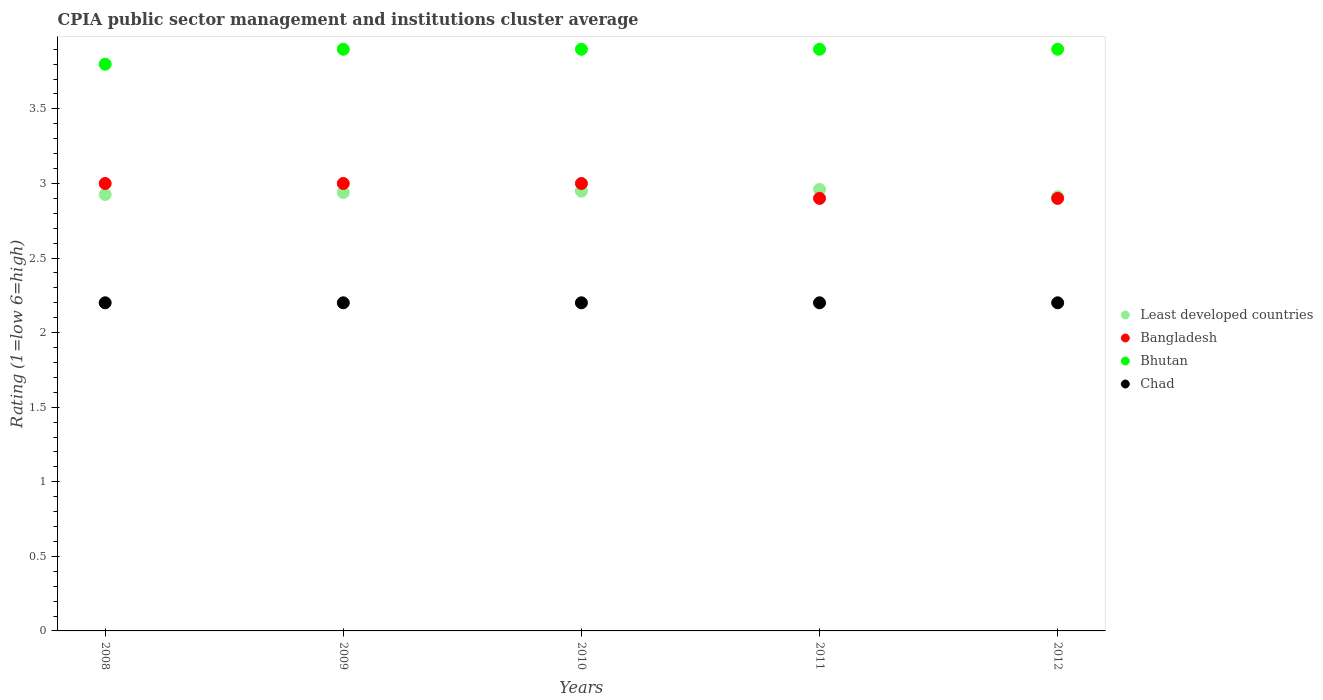How many different coloured dotlines are there?
Provide a succinct answer. 4. Is the number of dotlines equal to the number of legend labels?
Keep it short and to the point. Yes. What is the CPIA rating in Least developed countries in 2010?
Offer a terse response. 2.95. Across all years, what is the maximum CPIA rating in Bangladesh?
Make the answer very short. 3. What is the total CPIA rating in Bangladesh in the graph?
Make the answer very short. 14.8. What is the difference between the CPIA rating in Chad in 2008 and that in 2009?
Keep it short and to the point. 0. What is the difference between the CPIA rating in Bangladesh in 2010 and the CPIA rating in Bhutan in 2012?
Offer a very short reply. -0.9. What is the average CPIA rating in Chad per year?
Your response must be concise. 2.2. In how many years, is the CPIA rating in Bangladesh greater than 2.6?
Your answer should be very brief. 5. What is the ratio of the CPIA rating in Bangladesh in 2011 to that in 2012?
Offer a very short reply. 1. Is the CPIA rating in Bhutan in 2009 less than that in 2011?
Your answer should be compact. No. What is the difference between the highest and the lowest CPIA rating in Bhutan?
Your response must be concise. 0.1. In how many years, is the CPIA rating in Bangladesh greater than the average CPIA rating in Bangladesh taken over all years?
Give a very brief answer. 3. Is it the case that in every year, the sum of the CPIA rating in Least developed countries and CPIA rating in Bhutan  is greater than the sum of CPIA rating in Chad and CPIA rating in Bangladesh?
Provide a succinct answer. No. Is it the case that in every year, the sum of the CPIA rating in Chad and CPIA rating in Bangladesh  is greater than the CPIA rating in Least developed countries?
Offer a terse response. Yes. Does the CPIA rating in Chad monotonically increase over the years?
Offer a terse response. No. How many dotlines are there?
Keep it short and to the point. 4. Are the values on the major ticks of Y-axis written in scientific E-notation?
Offer a very short reply. No. How many legend labels are there?
Your answer should be compact. 4. How are the legend labels stacked?
Give a very brief answer. Vertical. What is the title of the graph?
Provide a short and direct response. CPIA public sector management and institutions cluster average. What is the Rating (1=low 6=high) in Least developed countries in 2008?
Give a very brief answer. 2.93. What is the Rating (1=low 6=high) in Least developed countries in 2009?
Ensure brevity in your answer.  2.94. What is the Rating (1=low 6=high) of Bangladesh in 2009?
Your answer should be compact. 3. What is the Rating (1=low 6=high) of Chad in 2009?
Your response must be concise. 2.2. What is the Rating (1=low 6=high) in Least developed countries in 2010?
Ensure brevity in your answer.  2.95. What is the Rating (1=low 6=high) in Bangladesh in 2010?
Provide a short and direct response. 3. What is the Rating (1=low 6=high) of Chad in 2010?
Give a very brief answer. 2.2. What is the Rating (1=low 6=high) in Least developed countries in 2011?
Give a very brief answer. 2.96. What is the Rating (1=low 6=high) of Bangladesh in 2011?
Provide a short and direct response. 2.9. What is the Rating (1=low 6=high) of Chad in 2011?
Provide a succinct answer. 2.2. What is the Rating (1=low 6=high) in Least developed countries in 2012?
Offer a very short reply. 2.91. What is the Rating (1=low 6=high) in Bhutan in 2012?
Provide a succinct answer. 3.9. What is the Rating (1=low 6=high) of Chad in 2012?
Offer a very short reply. 2.2. Across all years, what is the maximum Rating (1=low 6=high) of Least developed countries?
Give a very brief answer. 2.96. Across all years, what is the maximum Rating (1=low 6=high) of Bhutan?
Provide a short and direct response. 3.9. Across all years, what is the maximum Rating (1=low 6=high) in Chad?
Provide a succinct answer. 2.2. Across all years, what is the minimum Rating (1=low 6=high) in Least developed countries?
Give a very brief answer. 2.91. Across all years, what is the minimum Rating (1=low 6=high) of Bhutan?
Provide a succinct answer. 3.8. What is the total Rating (1=low 6=high) of Least developed countries in the graph?
Your answer should be compact. 14.69. What is the total Rating (1=low 6=high) of Bangladesh in the graph?
Provide a short and direct response. 14.8. What is the total Rating (1=low 6=high) in Bhutan in the graph?
Your answer should be compact. 19.4. What is the total Rating (1=low 6=high) in Chad in the graph?
Provide a short and direct response. 11. What is the difference between the Rating (1=low 6=high) in Least developed countries in 2008 and that in 2009?
Offer a terse response. -0.01. What is the difference between the Rating (1=low 6=high) in Bhutan in 2008 and that in 2009?
Your response must be concise. -0.1. What is the difference between the Rating (1=low 6=high) of Chad in 2008 and that in 2009?
Provide a succinct answer. 0. What is the difference between the Rating (1=low 6=high) in Least developed countries in 2008 and that in 2010?
Your answer should be very brief. -0.02. What is the difference between the Rating (1=low 6=high) in Bangladesh in 2008 and that in 2010?
Make the answer very short. 0. What is the difference between the Rating (1=low 6=high) in Bhutan in 2008 and that in 2010?
Offer a terse response. -0.1. What is the difference between the Rating (1=low 6=high) of Least developed countries in 2008 and that in 2011?
Your answer should be compact. -0.03. What is the difference between the Rating (1=low 6=high) in Least developed countries in 2008 and that in 2012?
Give a very brief answer. 0.02. What is the difference between the Rating (1=low 6=high) of Chad in 2008 and that in 2012?
Your response must be concise. 0. What is the difference between the Rating (1=low 6=high) in Least developed countries in 2009 and that in 2010?
Give a very brief answer. -0.01. What is the difference between the Rating (1=low 6=high) of Bhutan in 2009 and that in 2010?
Your response must be concise. 0. What is the difference between the Rating (1=low 6=high) of Chad in 2009 and that in 2010?
Make the answer very short. 0. What is the difference between the Rating (1=low 6=high) of Least developed countries in 2009 and that in 2011?
Offer a very short reply. -0.02. What is the difference between the Rating (1=low 6=high) of Bangladesh in 2009 and that in 2011?
Your answer should be compact. 0.1. What is the difference between the Rating (1=low 6=high) of Chad in 2009 and that in 2011?
Your answer should be very brief. 0. What is the difference between the Rating (1=low 6=high) of Least developed countries in 2009 and that in 2012?
Offer a very short reply. 0.03. What is the difference between the Rating (1=low 6=high) of Bhutan in 2009 and that in 2012?
Ensure brevity in your answer.  0. What is the difference between the Rating (1=low 6=high) of Least developed countries in 2010 and that in 2011?
Your answer should be compact. -0.01. What is the difference between the Rating (1=low 6=high) of Bangladesh in 2010 and that in 2011?
Provide a succinct answer. 0.1. What is the difference between the Rating (1=low 6=high) in Bhutan in 2010 and that in 2011?
Your response must be concise. 0. What is the difference between the Rating (1=low 6=high) in Least developed countries in 2010 and that in 2012?
Provide a succinct answer. 0.04. What is the difference between the Rating (1=low 6=high) in Bangladesh in 2010 and that in 2012?
Offer a terse response. 0.1. What is the difference between the Rating (1=low 6=high) in Chad in 2010 and that in 2012?
Provide a short and direct response. 0. What is the difference between the Rating (1=low 6=high) in Least developed countries in 2011 and that in 2012?
Keep it short and to the point. 0.05. What is the difference between the Rating (1=low 6=high) in Least developed countries in 2008 and the Rating (1=low 6=high) in Bangladesh in 2009?
Your response must be concise. -0.07. What is the difference between the Rating (1=low 6=high) in Least developed countries in 2008 and the Rating (1=low 6=high) in Bhutan in 2009?
Give a very brief answer. -0.97. What is the difference between the Rating (1=low 6=high) in Least developed countries in 2008 and the Rating (1=low 6=high) in Chad in 2009?
Provide a succinct answer. 0.73. What is the difference between the Rating (1=low 6=high) of Bangladesh in 2008 and the Rating (1=low 6=high) of Bhutan in 2009?
Make the answer very short. -0.9. What is the difference between the Rating (1=low 6=high) of Bangladesh in 2008 and the Rating (1=low 6=high) of Chad in 2009?
Keep it short and to the point. 0.8. What is the difference between the Rating (1=low 6=high) in Least developed countries in 2008 and the Rating (1=low 6=high) in Bangladesh in 2010?
Your answer should be compact. -0.07. What is the difference between the Rating (1=low 6=high) of Least developed countries in 2008 and the Rating (1=low 6=high) of Bhutan in 2010?
Offer a very short reply. -0.97. What is the difference between the Rating (1=low 6=high) of Least developed countries in 2008 and the Rating (1=low 6=high) of Chad in 2010?
Your answer should be very brief. 0.73. What is the difference between the Rating (1=low 6=high) of Bangladesh in 2008 and the Rating (1=low 6=high) of Bhutan in 2010?
Provide a succinct answer. -0.9. What is the difference between the Rating (1=low 6=high) in Bangladesh in 2008 and the Rating (1=low 6=high) in Chad in 2010?
Offer a very short reply. 0.8. What is the difference between the Rating (1=low 6=high) in Least developed countries in 2008 and the Rating (1=low 6=high) in Bangladesh in 2011?
Provide a succinct answer. 0.03. What is the difference between the Rating (1=low 6=high) in Least developed countries in 2008 and the Rating (1=low 6=high) in Bhutan in 2011?
Provide a succinct answer. -0.97. What is the difference between the Rating (1=low 6=high) in Least developed countries in 2008 and the Rating (1=low 6=high) in Chad in 2011?
Keep it short and to the point. 0.73. What is the difference between the Rating (1=low 6=high) of Bangladesh in 2008 and the Rating (1=low 6=high) of Bhutan in 2011?
Make the answer very short. -0.9. What is the difference between the Rating (1=low 6=high) in Least developed countries in 2008 and the Rating (1=low 6=high) in Bangladesh in 2012?
Offer a very short reply. 0.03. What is the difference between the Rating (1=low 6=high) of Least developed countries in 2008 and the Rating (1=low 6=high) of Bhutan in 2012?
Keep it short and to the point. -0.97. What is the difference between the Rating (1=low 6=high) of Least developed countries in 2008 and the Rating (1=low 6=high) of Chad in 2012?
Your response must be concise. 0.73. What is the difference between the Rating (1=low 6=high) of Bangladesh in 2008 and the Rating (1=low 6=high) of Bhutan in 2012?
Give a very brief answer. -0.9. What is the difference between the Rating (1=low 6=high) in Bangladesh in 2008 and the Rating (1=low 6=high) in Chad in 2012?
Provide a short and direct response. 0.8. What is the difference between the Rating (1=low 6=high) of Bhutan in 2008 and the Rating (1=low 6=high) of Chad in 2012?
Offer a terse response. 1.6. What is the difference between the Rating (1=low 6=high) in Least developed countries in 2009 and the Rating (1=low 6=high) in Bangladesh in 2010?
Ensure brevity in your answer.  -0.06. What is the difference between the Rating (1=low 6=high) in Least developed countries in 2009 and the Rating (1=low 6=high) in Bhutan in 2010?
Ensure brevity in your answer.  -0.96. What is the difference between the Rating (1=low 6=high) of Least developed countries in 2009 and the Rating (1=low 6=high) of Chad in 2010?
Your response must be concise. 0.74. What is the difference between the Rating (1=low 6=high) of Bangladesh in 2009 and the Rating (1=low 6=high) of Bhutan in 2010?
Ensure brevity in your answer.  -0.9. What is the difference between the Rating (1=low 6=high) of Bangladesh in 2009 and the Rating (1=low 6=high) of Chad in 2010?
Keep it short and to the point. 0.8. What is the difference between the Rating (1=low 6=high) in Least developed countries in 2009 and the Rating (1=low 6=high) in Bangladesh in 2011?
Provide a succinct answer. 0.04. What is the difference between the Rating (1=low 6=high) in Least developed countries in 2009 and the Rating (1=low 6=high) in Bhutan in 2011?
Keep it short and to the point. -0.96. What is the difference between the Rating (1=low 6=high) in Least developed countries in 2009 and the Rating (1=low 6=high) in Chad in 2011?
Keep it short and to the point. 0.74. What is the difference between the Rating (1=low 6=high) in Bangladesh in 2009 and the Rating (1=low 6=high) in Bhutan in 2011?
Offer a terse response. -0.9. What is the difference between the Rating (1=low 6=high) of Bangladesh in 2009 and the Rating (1=low 6=high) of Chad in 2011?
Make the answer very short. 0.8. What is the difference between the Rating (1=low 6=high) in Least developed countries in 2009 and the Rating (1=low 6=high) in Bangladesh in 2012?
Give a very brief answer. 0.04. What is the difference between the Rating (1=low 6=high) in Least developed countries in 2009 and the Rating (1=low 6=high) in Bhutan in 2012?
Provide a succinct answer. -0.96. What is the difference between the Rating (1=low 6=high) in Least developed countries in 2009 and the Rating (1=low 6=high) in Chad in 2012?
Your answer should be very brief. 0.74. What is the difference between the Rating (1=low 6=high) of Bangladesh in 2009 and the Rating (1=low 6=high) of Bhutan in 2012?
Provide a short and direct response. -0.9. What is the difference between the Rating (1=low 6=high) of Least developed countries in 2010 and the Rating (1=low 6=high) of Bangladesh in 2011?
Keep it short and to the point. 0.05. What is the difference between the Rating (1=low 6=high) in Least developed countries in 2010 and the Rating (1=low 6=high) in Bhutan in 2011?
Ensure brevity in your answer.  -0.95. What is the difference between the Rating (1=low 6=high) in Least developed countries in 2010 and the Rating (1=low 6=high) in Chad in 2011?
Your response must be concise. 0.75. What is the difference between the Rating (1=low 6=high) of Least developed countries in 2010 and the Rating (1=low 6=high) of Bangladesh in 2012?
Make the answer very short. 0.05. What is the difference between the Rating (1=low 6=high) of Least developed countries in 2010 and the Rating (1=low 6=high) of Bhutan in 2012?
Keep it short and to the point. -0.95. What is the difference between the Rating (1=low 6=high) in Least developed countries in 2010 and the Rating (1=low 6=high) in Chad in 2012?
Your response must be concise. 0.75. What is the difference between the Rating (1=low 6=high) of Bangladesh in 2010 and the Rating (1=low 6=high) of Chad in 2012?
Provide a short and direct response. 0.8. What is the difference between the Rating (1=low 6=high) in Least developed countries in 2011 and the Rating (1=low 6=high) in Bangladesh in 2012?
Provide a succinct answer. 0.06. What is the difference between the Rating (1=low 6=high) of Least developed countries in 2011 and the Rating (1=low 6=high) of Bhutan in 2012?
Offer a terse response. -0.94. What is the difference between the Rating (1=low 6=high) of Least developed countries in 2011 and the Rating (1=low 6=high) of Chad in 2012?
Keep it short and to the point. 0.76. What is the difference between the Rating (1=low 6=high) of Bangladesh in 2011 and the Rating (1=low 6=high) of Chad in 2012?
Offer a terse response. 0.7. What is the difference between the Rating (1=low 6=high) of Bhutan in 2011 and the Rating (1=low 6=high) of Chad in 2012?
Keep it short and to the point. 1.7. What is the average Rating (1=low 6=high) of Least developed countries per year?
Provide a succinct answer. 2.94. What is the average Rating (1=low 6=high) in Bangladesh per year?
Ensure brevity in your answer.  2.96. What is the average Rating (1=low 6=high) in Bhutan per year?
Your answer should be very brief. 3.88. In the year 2008, what is the difference between the Rating (1=low 6=high) in Least developed countries and Rating (1=low 6=high) in Bangladesh?
Give a very brief answer. -0.07. In the year 2008, what is the difference between the Rating (1=low 6=high) in Least developed countries and Rating (1=low 6=high) in Bhutan?
Give a very brief answer. -0.87. In the year 2008, what is the difference between the Rating (1=low 6=high) in Least developed countries and Rating (1=low 6=high) in Chad?
Keep it short and to the point. 0.73. In the year 2008, what is the difference between the Rating (1=low 6=high) of Bangladesh and Rating (1=low 6=high) of Bhutan?
Your answer should be compact. -0.8. In the year 2008, what is the difference between the Rating (1=low 6=high) of Bangladesh and Rating (1=low 6=high) of Chad?
Your response must be concise. 0.8. In the year 2009, what is the difference between the Rating (1=low 6=high) in Least developed countries and Rating (1=low 6=high) in Bangladesh?
Offer a terse response. -0.06. In the year 2009, what is the difference between the Rating (1=low 6=high) in Least developed countries and Rating (1=low 6=high) in Bhutan?
Provide a succinct answer. -0.96. In the year 2009, what is the difference between the Rating (1=low 6=high) of Least developed countries and Rating (1=low 6=high) of Chad?
Your response must be concise. 0.74. In the year 2009, what is the difference between the Rating (1=low 6=high) in Bangladesh and Rating (1=low 6=high) in Bhutan?
Your answer should be very brief. -0.9. In the year 2009, what is the difference between the Rating (1=low 6=high) of Bangladesh and Rating (1=low 6=high) of Chad?
Ensure brevity in your answer.  0.8. In the year 2009, what is the difference between the Rating (1=low 6=high) in Bhutan and Rating (1=low 6=high) in Chad?
Provide a succinct answer. 1.7. In the year 2010, what is the difference between the Rating (1=low 6=high) in Least developed countries and Rating (1=low 6=high) in Bangladesh?
Your answer should be compact. -0.05. In the year 2010, what is the difference between the Rating (1=low 6=high) of Least developed countries and Rating (1=low 6=high) of Bhutan?
Provide a succinct answer. -0.95. In the year 2010, what is the difference between the Rating (1=low 6=high) in Least developed countries and Rating (1=low 6=high) in Chad?
Offer a very short reply. 0.75. In the year 2010, what is the difference between the Rating (1=low 6=high) in Bangladesh and Rating (1=low 6=high) in Chad?
Ensure brevity in your answer.  0.8. In the year 2010, what is the difference between the Rating (1=low 6=high) of Bhutan and Rating (1=low 6=high) of Chad?
Provide a succinct answer. 1.7. In the year 2011, what is the difference between the Rating (1=low 6=high) in Least developed countries and Rating (1=low 6=high) in Bangladesh?
Your answer should be compact. 0.06. In the year 2011, what is the difference between the Rating (1=low 6=high) of Least developed countries and Rating (1=low 6=high) of Bhutan?
Keep it short and to the point. -0.94. In the year 2011, what is the difference between the Rating (1=low 6=high) in Least developed countries and Rating (1=low 6=high) in Chad?
Your answer should be very brief. 0.76. In the year 2011, what is the difference between the Rating (1=low 6=high) in Bangladesh and Rating (1=low 6=high) in Chad?
Ensure brevity in your answer.  0.7. In the year 2012, what is the difference between the Rating (1=low 6=high) of Least developed countries and Rating (1=low 6=high) of Bangladesh?
Offer a terse response. 0.01. In the year 2012, what is the difference between the Rating (1=low 6=high) in Least developed countries and Rating (1=low 6=high) in Bhutan?
Offer a terse response. -0.99. In the year 2012, what is the difference between the Rating (1=low 6=high) in Least developed countries and Rating (1=low 6=high) in Chad?
Your answer should be very brief. 0.71. In the year 2012, what is the difference between the Rating (1=low 6=high) of Bangladesh and Rating (1=low 6=high) of Bhutan?
Offer a terse response. -1. In the year 2012, what is the difference between the Rating (1=low 6=high) of Bangladesh and Rating (1=low 6=high) of Chad?
Your answer should be compact. 0.7. In the year 2012, what is the difference between the Rating (1=low 6=high) of Bhutan and Rating (1=low 6=high) of Chad?
Your answer should be very brief. 1.7. What is the ratio of the Rating (1=low 6=high) in Bhutan in 2008 to that in 2009?
Give a very brief answer. 0.97. What is the ratio of the Rating (1=low 6=high) of Bhutan in 2008 to that in 2010?
Provide a succinct answer. 0.97. What is the ratio of the Rating (1=low 6=high) in Least developed countries in 2008 to that in 2011?
Make the answer very short. 0.99. What is the ratio of the Rating (1=low 6=high) of Bangladesh in 2008 to that in 2011?
Offer a very short reply. 1.03. What is the ratio of the Rating (1=low 6=high) of Bhutan in 2008 to that in 2011?
Provide a short and direct response. 0.97. What is the ratio of the Rating (1=low 6=high) of Chad in 2008 to that in 2011?
Offer a very short reply. 1. What is the ratio of the Rating (1=low 6=high) in Least developed countries in 2008 to that in 2012?
Your response must be concise. 1.01. What is the ratio of the Rating (1=low 6=high) in Bangladesh in 2008 to that in 2012?
Ensure brevity in your answer.  1.03. What is the ratio of the Rating (1=low 6=high) of Bhutan in 2008 to that in 2012?
Give a very brief answer. 0.97. What is the ratio of the Rating (1=low 6=high) of Least developed countries in 2009 to that in 2010?
Make the answer very short. 1. What is the ratio of the Rating (1=low 6=high) in Bhutan in 2009 to that in 2010?
Make the answer very short. 1. What is the ratio of the Rating (1=low 6=high) of Chad in 2009 to that in 2010?
Offer a very short reply. 1. What is the ratio of the Rating (1=low 6=high) in Least developed countries in 2009 to that in 2011?
Your answer should be very brief. 0.99. What is the ratio of the Rating (1=low 6=high) of Bangladesh in 2009 to that in 2011?
Make the answer very short. 1.03. What is the ratio of the Rating (1=low 6=high) of Chad in 2009 to that in 2011?
Ensure brevity in your answer.  1. What is the ratio of the Rating (1=low 6=high) of Least developed countries in 2009 to that in 2012?
Make the answer very short. 1.01. What is the ratio of the Rating (1=low 6=high) in Bangladesh in 2009 to that in 2012?
Your response must be concise. 1.03. What is the ratio of the Rating (1=low 6=high) of Least developed countries in 2010 to that in 2011?
Your response must be concise. 1. What is the ratio of the Rating (1=low 6=high) of Bangladesh in 2010 to that in 2011?
Offer a very short reply. 1.03. What is the ratio of the Rating (1=low 6=high) of Bhutan in 2010 to that in 2011?
Your answer should be very brief. 1. What is the ratio of the Rating (1=low 6=high) of Chad in 2010 to that in 2011?
Give a very brief answer. 1. What is the ratio of the Rating (1=low 6=high) in Least developed countries in 2010 to that in 2012?
Keep it short and to the point. 1.01. What is the ratio of the Rating (1=low 6=high) of Bangladesh in 2010 to that in 2012?
Offer a terse response. 1.03. What is the ratio of the Rating (1=low 6=high) of Chad in 2010 to that in 2012?
Ensure brevity in your answer.  1. What is the ratio of the Rating (1=low 6=high) in Bangladesh in 2011 to that in 2012?
Offer a very short reply. 1. What is the ratio of the Rating (1=low 6=high) of Bhutan in 2011 to that in 2012?
Offer a terse response. 1. What is the ratio of the Rating (1=low 6=high) of Chad in 2011 to that in 2012?
Your answer should be very brief. 1. What is the difference between the highest and the second highest Rating (1=low 6=high) in Least developed countries?
Provide a short and direct response. 0.01. What is the difference between the highest and the second highest Rating (1=low 6=high) in Bangladesh?
Give a very brief answer. 0. What is the difference between the highest and the second highest Rating (1=low 6=high) of Bhutan?
Your answer should be very brief. 0. What is the difference between the highest and the lowest Rating (1=low 6=high) in Least developed countries?
Provide a succinct answer. 0.05. What is the difference between the highest and the lowest Rating (1=low 6=high) in Bhutan?
Provide a short and direct response. 0.1. 